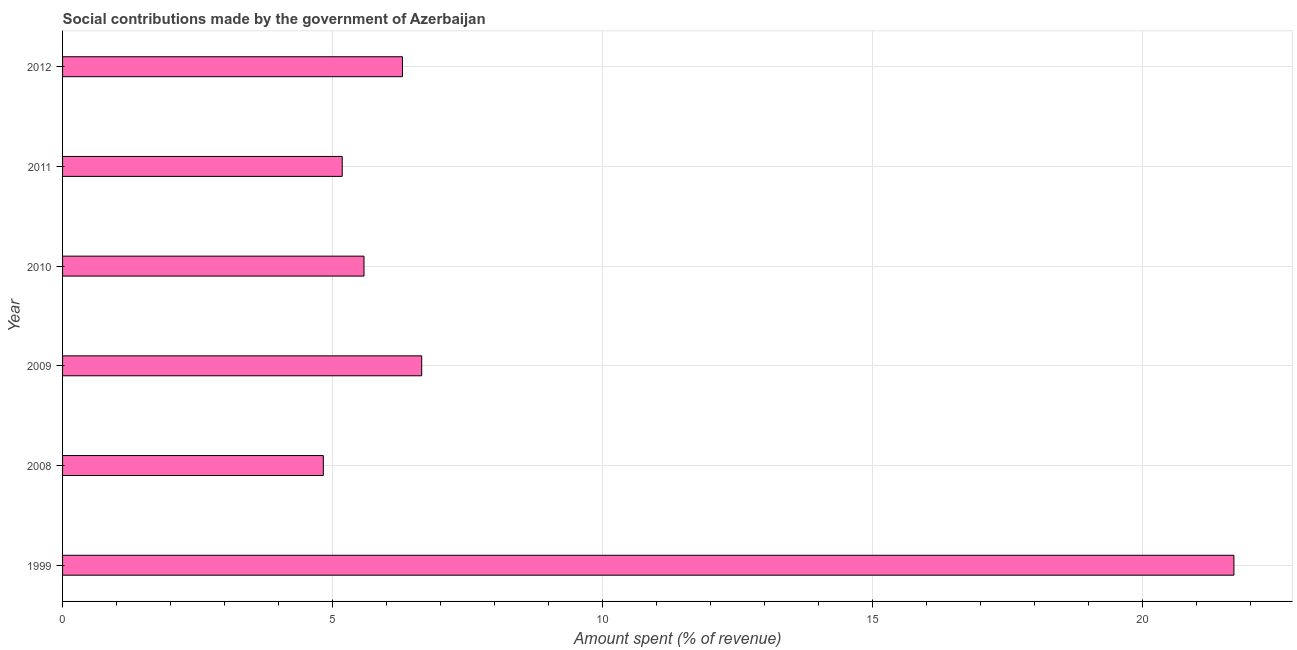What is the title of the graph?
Provide a short and direct response. Social contributions made by the government of Azerbaijan. What is the label or title of the X-axis?
Ensure brevity in your answer.  Amount spent (% of revenue). What is the amount spent in making social contributions in 2008?
Your answer should be very brief. 4.83. Across all years, what is the maximum amount spent in making social contributions?
Give a very brief answer. 21.69. Across all years, what is the minimum amount spent in making social contributions?
Provide a short and direct response. 4.83. In which year was the amount spent in making social contributions maximum?
Provide a succinct answer. 1999. What is the sum of the amount spent in making social contributions?
Ensure brevity in your answer.  50.21. What is the difference between the amount spent in making social contributions in 1999 and 2008?
Make the answer very short. 16.86. What is the average amount spent in making social contributions per year?
Ensure brevity in your answer.  8.37. What is the median amount spent in making social contributions?
Your answer should be very brief. 5.94. In how many years, is the amount spent in making social contributions greater than 2 %?
Offer a terse response. 6. What is the ratio of the amount spent in making social contributions in 2009 to that in 2012?
Your response must be concise. 1.06. Is the amount spent in making social contributions in 2008 less than that in 2012?
Your answer should be very brief. Yes. Is the difference between the amount spent in making social contributions in 2008 and 2011 greater than the difference between any two years?
Offer a terse response. No. What is the difference between the highest and the second highest amount spent in making social contributions?
Offer a very short reply. 15.04. What is the difference between the highest and the lowest amount spent in making social contributions?
Keep it short and to the point. 16.86. In how many years, is the amount spent in making social contributions greater than the average amount spent in making social contributions taken over all years?
Give a very brief answer. 1. How many years are there in the graph?
Offer a very short reply. 6. What is the Amount spent (% of revenue) in 1999?
Offer a terse response. 21.69. What is the Amount spent (% of revenue) in 2008?
Give a very brief answer. 4.83. What is the Amount spent (% of revenue) in 2009?
Your answer should be very brief. 6.65. What is the Amount spent (% of revenue) of 2010?
Make the answer very short. 5.58. What is the Amount spent (% of revenue) of 2011?
Offer a terse response. 5.18. What is the Amount spent (% of revenue) of 2012?
Offer a terse response. 6.29. What is the difference between the Amount spent (% of revenue) in 1999 and 2008?
Ensure brevity in your answer.  16.86. What is the difference between the Amount spent (% of revenue) in 1999 and 2009?
Your answer should be compact. 15.04. What is the difference between the Amount spent (% of revenue) in 1999 and 2010?
Your response must be concise. 16.1. What is the difference between the Amount spent (% of revenue) in 1999 and 2011?
Your response must be concise. 16.51. What is the difference between the Amount spent (% of revenue) in 1999 and 2012?
Provide a succinct answer. 15.39. What is the difference between the Amount spent (% of revenue) in 2008 and 2009?
Ensure brevity in your answer.  -1.82. What is the difference between the Amount spent (% of revenue) in 2008 and 2010?
Your answer should be very brief. -0.75. What is the difference between the Amount spent (% of revenue) in 2008 and 2011?
Offer a very short reply. -0.35. What is the difference between the Amount spent (% of revenue) in 2008 and 2012?
Your answer should be compact. -1.46. What is the difference between the Amount spent (% of revenue) in 2009 and 2010?
Your answer should be very brief. 1.07. What is the difference between the Amount spent (% of revenue) in 2009 and 2011?
Make the answer very short. 1.47. What is the difference between the Amount spent (% of revenue) in 2009 and 2012?
Your answer should be very brief. 0.36. What is the difference between the Amount spent (% of revenue) in 2010 and 2011?
Give a very brief answer. 0.4. What is the difference between the Amount spent (% of revenue) in 2010 and 2012?
Provide a succinct answer. -0.71. What is the difference between the Amount spent (% of revenue) in 2011 and 2012?
Keep it short and to the point. -1.11. What is the ratio of the Amount spent (% of revenue) in 1999 to that in 2008?
Your answer should be very brief. 4.49. What is the ratio of the Amount spent (% of revenue) in 1999 to that in 2009?
Offer a very short reply. 3.26. What is the ratio of the Amount spent (% of revenue) in 1999 to that in 2010?
Provide a short and direct response. 3.89. What is the ratio of the Amount spent (% of revenue) in 1999 to that in 2011?
Give a very brief answer. 4.19. What is the ratio of the Amount spent (% of revenue) in 1999 to that in 2012?
Offer a very short reply. 3.45. What is the ratio of the Amount spent (% of revenue) in 2008 to that in 2009?
Provide a succinct answer. 0.73. What is the ratio of the Amount spent (% of revenue) in 2008 to that in 2010?
Offer a terse response. 0.86. What is the ratio of the Amount spent (% of revenue) in 2008 to that in 2011?
Your answer should be very brief. 0.93. What is the ratio of the Amount spent (% of revenue) in 2008 to that in 2012?
Offer a very short reply. 0.77. What is the ratio of the Amount spent (% of revenue) in 2009 to that in 2010?
Offer a terse response. 1.19. What is the ratio of the Amount spent (% of revenue) in 2009 to that in 2011?
Offer a very short reply. 1.28. What is the ratio of the Amount spent (% of revenue) in 2009 to that in 2012?
Offer a very short reply. 1.06. What is the ratio of the Amount spent (% of revenue) in 2010 to that in 2011?
Your answer should be very brief. 1.08. What is the ratio of the Amount spent (% of revenue) in 2010 to that in 2012?
Offer a terse response. 0.89. What is the ratio of the Amount spent (% of revenue) in 2011 to that in 2012?
Your response must be concise. 0.82. 